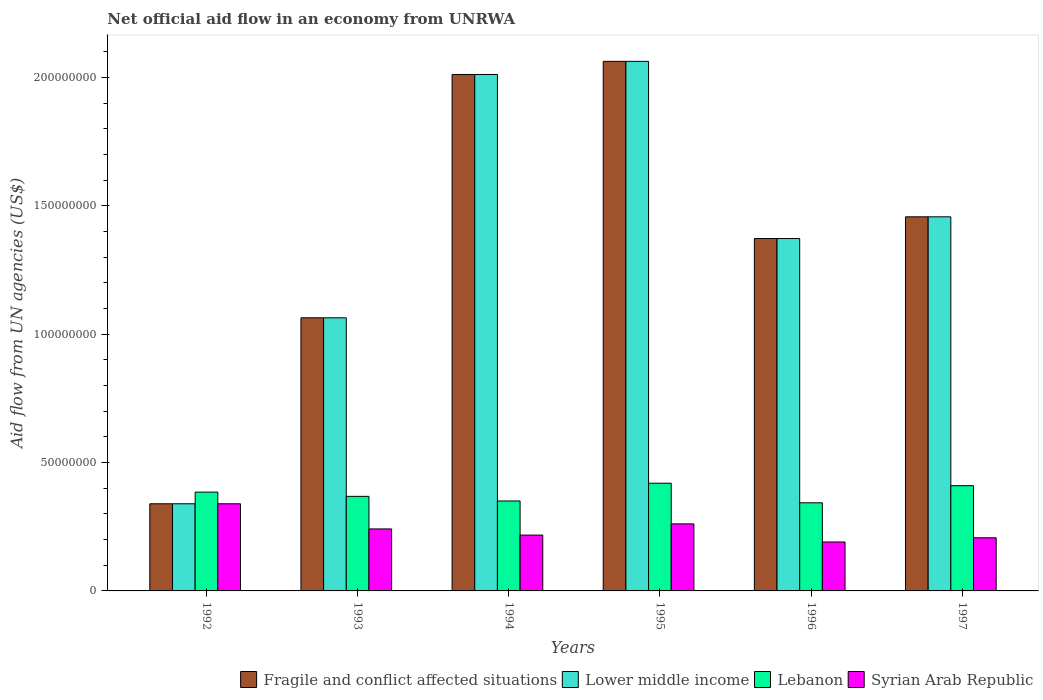How many bars are there on the 4th tick from the left?
Your answer should be very brief. 4. How many bars are there on the 3rd tick from the right?
Your answer should be very brief. 4. What is the label of the 1st group of bars from the left?
Make the answer very short. 1992. What is the net official aid flow in Fragile and conflict affected situations in 1997?
Provide a succinct answer. 1.46e+08. Across all years, what is the maximum net official aid flow in Fragile and conflict affected situations?
Your answer should be very brief. 2.06e+08. Across all years, what is the minimum net official aid flow in Fragile and conflict affected situations?
Offer a terse response. 3.40e+07. In which year was the net official aid flow in Lebanon minimum?
Offer a terse response. 1996. What is the total net official aid flow in Lower middle income in the graph?
Offer a terse response. 8.31e+08. What is the difference between the net official aid flow in Lower middle income in 1993 and that in 1994?
Provide a succinct answer. -9.48e+07. What is the difference between the net official aid flow in Lebanon in 1997 and the net official aid flow in Lower middle income in 1994?
Provide a succinct answer. -1.60e+08. What is the average net official aid flow in Lebanon per year?
Keep it short and to the point. 3.79e+07. In the year 1994, what is the difference between the net official aid flow in Lower middle income and net official aid flow in Lebanon?
Offer a terse response. 1.66e+08. In how many years, is the net official aid flow in Fragile and conflict affected situations greater than 160000000 US$?
Your answer should be compact. 2. What is the ratio of the net official aid flow in Lebanon in 1995 to that in 1996?
Offer a very short reply. 1.22. What is the difference between the highest and the second highest net official aid flow in Lower middle income?
Provide a succinct answer. 5.11e+06. What is the difference between the highest and the lowest net official aid flow in Fragile and conflict affected situations?
Make the answer very short. 1.72e+08. In how many years, is the net official aid flow in Lower middle income greater than the average net official aid flow in Lower middle income taken over all years?
Your answer should be very brief. 3. Is the sum of the net official aid flow in Lower middle income in 1992 and 1995 greater than the maximum net official aid flow in Lebanon across all years?
Your response must be concise. Yes. Is it the case that in every year, the sum of the net official aid flow in Fragile and conflict affected situations and net official aid flow in Syrian Arab Republic is greater than the sum of net official aid flow in Lebanon and net official aid flow in Lower middle income?
Your response must be concise. No. What does the 2nd bar from the left in 1992 represents?
Offer a terse response. Lower middle income. What does the 4th bar from the right in 1997 represents?
Your answer should be compact. Fragile and conflict affected situations. Is it the case that in every year, the sum of the net official aid flow in Lower middle income and net official aid flow in Syrian Arab Republic is greater than the net official aid flow in Fragile and conflict affected situations?
Offer a terse response. Yes. How many bars are there?
Give a very brief answer. 24. Are all the bars in the graph horizontal?
Offer a very short reply. No. What is the difference between two consecutive major ticks on the Y-axis?
Ensure brevity in your answer.  5.00e+07. Are the values on the major ticks of Y-axis written in scientific E-notation?
Give a very brief answer. No. Does the graph contain any zero values?
Give a very brief answer. No. What is the title of the graph?
Your response must be concise. Net official aid flow in an economy from UNRWA. Does "Micronesia" appear as one of the legend labels in the graph?
Your response must be concise. No. What is the label or title of the Y-axis?
Your answer should be compact. Aid flow from UN agencies (US$). What is the Aid flow from UN agencies (US$) of Fragile and conflict affected situations in 1992?
Make the answer very short. 3.40e+07. What is the Aid flow from UN agencies (US$) of Lower middle income in 1992?
Keep it short and to the point. 3.40e+07. What is the Aid flow from UN agencies (US$) in Lebanon in 1992?
Your answer should be compact. 3.85e+07. What is the Aid flow from UN agencies (US$) in Syrian Arab Republic in 1992?
Your answer should be compact. 3.40e+07. What is the Aid flow from UN agencies (US$) of Fragile and conflict affected situations in 1993?
Your answer should be compact. 1.06e+08. What is the Aid flow from UN agencies (US$) in Lower middle income in 1993?
Keep it short and to the point. 1.06e+08. What is the Aid flow from UN agencies (US$) of Lebanon in 1993?
Give a very brief answer. 3.68e+07. What is the Aid flow from UN agencies (US$) of Syrian Arab Republic in 1993?
Provide a short and direct response. 2.42e+07. What is the Aid flow from UN agencies (US$) in Fragile and conflict affected situations in 1994?
Your answer should be compact. 2.01e+08. What is the Aid flow from UN agencies (US$) in Lower middle income in 1994?
Your answer should be very brief. 2.01e+08. What is the Aid flow from UN agencies (US$) of Lebanon in 1994?
Provide a short and direct response. 3.50e+07. What is the Aid flow from UN agencies (US$) in Syrian Arab Republic in 1994?
Give a very brief answer. 2.18e+07. What is the Aid flow from UN agencies (US$) of Fragile and conflict affected situations in 1995?
Ensure brevity in your answer.  2.06e+08. What is the Aid flow from UN agencies (US$) of Lower middle income in 1995?
Provide a short and direct response. 2.06e+08. What is the Aid flow from UN agencies (US$) in Lebanon in 1995?
Give a very brief answer. 4.20e+07. What is the Aid flow from UN agencies (US$) of Syrian Arab Republic in 1995?
Keep it short and to the point. 2.61e+07. What is the Aid flow from UN agencies (US$) in Fragile and conflict affected situations in 1996?
Give a very brief answer. 1.37e+08. What is the Aid flow from UN agencies (US$) in Lower middle income in 1996?
Give a very brief answer. 1.37e+08. What is the Aid flow from UN agencies (US$) of Lebanon in 1996?
Ensure brevity in your answer.  3.43e+07. What is the Aid flow from UN agencies (US$) of Syrian Arab Republic in 1996?
Provide a short and direct response. 1.91e+07. What is the Aid flow from UN agencies (US$) in Fragile and conflict affected situations in 1997?
Keep it short and to the point. 1.46e+08. What is the Aid flow from UN agencies (US$) of Lower middle income in 1997?
Provide a short and direct response. 1.46e+08. What is the Aid flow from UN agencies (US$) in Lebanon in 1997?
Your response must be concise. 4.10e+07. What is the Aid flow from UN agencies (US$) of Syrian Arab Republic in 1997?
Make the answer very short. 2.07e+07. Across all years, what is the maximum Aid flow from UN agencies (US$) of Fragile and conflict affected situations?
Your answer should be compact. 2.06e+08. Across all years, what is the maximum Aid flow from UN agencies (US$) in Lower middle income?
Offer a very short reply. 2.06e+08. Across all years, what is the maximum Aid flow from UN agencies (US$) in Lebanon?
Your response must be concise. 4.20e+07. Across all years, what is the maximum Aid flow from UN agencies (US$) in Syrian Arab Republic?
Your answer should be very brief. 3.40e+07. Across all years, what is the minimum Aid flow from UN agencies (US$) in Fragile and conflict affected situations?
Provide a succinct answer. 3.40e+07. Across all years, what is the minimum Aid flow from UN agencies (US$) of Lower middle income?
Offer a very short reply. 3.40e+07. Across all years, what is the minimum Aid flow from UN agencies (US$) in Lebanon?
Offer a very short reply. 3.43e+07. Across all years, what is the minimum Aid flow from UN agencies (US$) in Syrian Arab Republic?
Give a very brief answer. 1.91e+07. What is the total Aid flow from UN agencies (US$) of Fragile and conflict affected situations in the graph?
Ensure brevity in your answer.  8.31e+08. What is the total Aid flow from UN agencies (US$) of Lower middle income in the graph?
Your response must be concise. 8.31e+08. What is the total Aid flow from UN agencies (US$) in Lebanon in the graph?
Ensure brevity in your answer.  2.28e+08. What is the total Aid flow from UN agencies (US$) in Syrian Arab Republic in the graph?
Give a very brief answer. 1.46e+08. What is the difference between the Aid flow from UN agencies (US$) of Fragile and conflict affected situations in 1992 and that in 1993?
Your answer should be compact. -7.24e+07. What is the difference between the Aid flow from UN agencies (US$) of Lower middle income in 1992 and that in 1993?
Offer a terse response. -7.24e+07. What is the difference between the Aid flow from UN agencies (US$) of Lebanon in 1992 and that in 1993?
Make the answer very short. 1.66e+06. What is the difference between the Aid flow from UN agencies (US$) in Syrian Arab Republic in 1992 and that in 1993?
Ensure brevity in your answer.  9.80e+06. What is the difference between the Aid flow from UN agencies (US$) in Fragile and conflict affected situations in 1992 and that in 1994?
Provide a short and direct response. -1.67e+08. What is the difference between the Aid flow from UN agencies (US$) of Lower middle income in 1992 and that in 1994?
Your response must be concise. -1.67e+08. What is the difference between the Aid flow from UN agencies (US$) of Lebanon in 1992 and that in 1994?
Your answer should be compact. 3.46e+06. What is the difference between the Aid flow from UN agencies (US$) of Syrian Arab Republic in 1992 and that in 1994?
Make the answer very short. 1.22e+07. What is the difference between the Aid flow from UN agencies (US$) in Fragile and conflict affected situations in 1992 and that in 1995?
Make the answer very short. -1.72e+08. What is the difference between the Aid flow from UN agencies (US$) of Lower middle income in 1992 and that in 1995?
Provide a short and direct response. -1.72e+08. What is the difference between the Aid flow from UN agencies (US$) in Lebanon in 1992 and that in 1995?
Give a very brief answer. -3.46e+06. What is the difference between the Aid flow from UN agencies (US$) in Syrian Arab Republic in 1992 and that in 1995?
Give a very brief answer. 7.84e+06. What is the difference between the Aid flow from UN agencies (US$) in Fragile and conflict affected situations in 1992 and that in 1996?
Keep it short and to the point. -1.03e+08. What is the difference between the Aid flow from UN agencies (US$) in Lower middle income in 1992 and that in 1996?
Make the answer very short. -1.03e+08. What is the difference between the Aid flow from UN agencies (US$) in Lebanon in 1992 and that in 1996?
Provide a short and direct response. 4.17e+06. What is the difference between the Aid flow from UN agencies (US$) of Syrian Arab Republic in 1992 and that in 1996?
Make the answer very short. 1.49e+07. What is the difference between the Aid flow from UN agencies (US$) in Fragile and conflict affected situations in 1992 and that in 1997?
Provide a short and direct response. -1.12e+08. What is the difference between the Aid flow from UN agencies (US$) of Lower middle income in 1992 and that in 1997?
Your answer should be very brief. -1.12e+08. What is the difference between the Aid flow from UN agencies (US$) in Lebanon in 1992 and that in 1997?
Provide a succinct answer. -2.50e+06. What is the difference between the Aid flow from UN agencies (US$) of Syrian Arab Republic in 1992 and that in 1997?
Provide a short and direct response. 1.32e+07. What is the difference between the Aid flow from UN agencies (US$) of Fragile and conflict affected situations in 1993 and that in 1994?
Keep it short and to the point. -9.48e+07. What is the difference between the Aid flow from UN agencies (US$) of Lower middle income in 1993 and that in 1994?
Ensure brevity in your answer.  -9.48e+07. What is the difference between the Aid flow from UN agencies (US$) of Lebanon in 1993 and that in 1994?
Provide a succinct answer. 1.80e+06. What is the difference between the Aid flow from UN agencies (US$) in Syrian Arab Republic in 1993 and that in 1994?
Your answer should be very brief. 2.40e+06. What is the difference between the Aid flow from UN agencies (US$) in Fragile and conflict affected situations in 1993 and that in 1995?
Offer a very short reply. -9.99e+07. What is the difference between the Aid flow from UN agencies (US$) in Lower middle income in 1993 and that in 1995?
Provide a succinct answer. -9.99e+07. What is the difference between the Aid flow from UN agencies (US$) in Lebanon in 1993 and that in 1995?
Keep it short and to the point. -5.12e+06. What is the difference between the Aid flow from UN agencies (US$) of Syrian Arab Republic in 1993 and that in 1995?
Your answer should be compact. -1.96e+06. What is the difference between the Aid flow from UN agencies (US$) of Fragile and conflict affected situations in 1993 and that in 1996?
Offer a terse response. -3.09e+07. What is the difference between the Aid flow from UN agencies (US$) in Lower middle income in 1993 and that in 1996?
Make the answer very short. -3.09e+07. What is the difference between the Aid flow from UN agencies (US$) of Lebanon in 1993 and that in 1996?
Make the answer very short. 2.51e+06. What is the difference between the Aid flow from UN agencies (US$) of Syrian Arab Republic in 1993 and that in 1996?
Provide a short and direct response. 5.09e+06. What is the difference between the Aid flow from UN agencies (US$) of Fragile and conflict affected situations in 1993 and that in 1997?
Your response must be concise. -3.93e+07. What is the difference between the Aid flow from UN agencies (US$) of Lower middle income in 1993 and that in 1997?
Give a very brief answer. -3.93e+07. What is the difference between the Aid flow from UN agencies (US$) of Lebanon in 1993 and that in 1997?
Offer a very short reply. -4.16e+06. What is the difference between the Aid flow from UN agencies (US$) in Syrian Arab Republic in 1993 and that in 1997?
Give a very brief answer. 3.45e+06. What is the difference between the Aid flow from UN agencies (US$) in Fragile and conflict affected situations in 1994 and that in 1995?
Keep it short and to the point. -5.11e+06. What is the difference between the Aid flow from UN agencies (US$) in Lower middle income in 1994 and that in 1995?
Give a very brief answer. -5.11e+06. What is the difference between the Aid flow from UN agencies (US$) in Lebanon in 1994 and that in 1995?
Your response must be concise. -6.92e+06. What is the difference between the Aid flow from UN agencies (US$) of Syrian Arab Republic in 1994 and that in 1995?
Keep it short and to the point. -4.36e+06. What is the difference between the Aid flow from UN agencies (US$) of Fragile and conflict affected situations in 1994 and that in 1996?
Provide a succinct answer. 6.39e+07. What is the difference between the Aid flow from UN agencies (US$) of Lower middle income in 1994 and that in 1996?
Ensure brevity in your answer.  6.39e+07. What is the difference between the Aid flow from UN agencies (US$) of Lebanon in 1994 and that in 1996?
Offer a terse response. 7.10e+05. What is the difference between the Aid flow from UN agencies (US$) in Syrian Arab Republic in 1994 and that in 1996?
Offer a very short reply. 2.69e+06. What is the difference between the Aid flow from UN agencies (US$) in Fragile and conflict affected situations in 1994 and that in 1997?
Offer a terse response. 5.55e+07. What is the difference between the Aid flow from UN agencies (US$) in Lower middle income in 1994 and that in 1997?
Make the answer very short. 5.55e+07. What is the difference between the Aid flow from UN agencies (US$) in Lebanon in 1994 and that in 1997?
Offer a very short reply. -5.96e+06. What is the difference between the Aid flow from UN agencies (US$) of Syrian Arab Republic in 1994 and that in 1997?
Your answer should be very brief. 1.05e+06. What is the difference between the Aid flow from UN agencies (US$) of Fragile and conflict affected situations in 1995 and that in 1996?
Offer a very short reply. 6.90e+07. What is the difference between the Aid flow from UN agencies (US$) of Lower middle income in 1995 and that in 1996?
Ensure brevity in your answer.  6.90e+07. What is the difference between the Aid flow from UN agencies (US$) of Lebanon in 1995 and that in 1996?
Provide a succinct answer. 7.63e+06. What is the difference between the Aid flow from UN agencies (US$) of Syrian Arab Republic in 1995 and that in 1996?
Give a very brief answer. 7.05e+06. What is the difference between the Aid flow from UN agencies (US$) of Fragile and conflict affected situations in 1995 and that in 1997?
Your answer should be very brief. 6.06e+07. What is the difference between the Aid flow from UN agencies (US$) in Lower middle income in 1995 and that in 1997?
Offer a very short reply. 6.06e+07. What is the difference between the Aid flow from UN agencies (US$) in Lebanon in 1995 and that in 1997?
Your answer should be compact. 9.60e+05. What is the difference between the Aid flow from UN agencies (US$) in Syrian Arab Republic in 1995 and that in 1997?
Provide a succinct answer. 5.41e+06. What is the difference between the Aid flow from UN agencies (US$) of Fragile and conflict affected situations in 1996 and that in 1997?
Make the answer very short. -8.46e+06. What is the difference between the Aid flow from UN agencies (US$) of Lower middle income in 1996 and that in 1997?
Provide a succinct answer. -8.46e+06. What is the difference between the Aid flow from UN agencies (US$) of Lebanon in 1996 and that in 1997?
Provide a short and direct response. -6.67e+06. What is the difference between the Aid flow from UN agencies (US$) of Syrian Arab Republic in 1996 and that in 1997?
Make the answer very short. -1.64e+06. What is the difference between the Aid flow from UN agencies (US$) in Fragile and conflict affected situations in 1992 and the Aid flow from UN agencies (US$) in Lower middle income in 1993?
Provide a succinct answer. -7.24e+07. What is the difference between the Aid flow from UN agencies (US$) in Fragile and conflict affected situations in 1992 and the Aid flow from UN agencies (US$) in Lebanon in 1993?
Your response must be concise. -2.89e+06. What is the difference between the Aid flow from UN agencies (US$) in Fragile and conflict affected situations in 1992 and the Aid flow from UN agencies (US$) in Syrian Arab Republic in 1993?
Your answer should be very brief. 9.80e+06. What is the difference between the Aid flow from UN agencies (US$) of Lower middle income in 1992 and the Aid flow from UN agencies (US$) of Lebanon in 1993?
Provide a short and direct response. -2.89e+06. What is the difference between the Aid flow from UN agencies (US$) of Lower middle income in 1992 and the Aid flow from UN agencies (US$) of Syrian Arab Republic in 1993?
Give a very brief answer. 9.80e+06. What is the difference between the Aid flow from UN agencies (US$) of Lebanon in 1992 and the Aid flow from UN agencies (US$) of Syrian Arab Republic in 1993?
Your response must be concise. 1.44e+07. What is the difference between the Aid flow from UN agencies (US$) in Fragile and conflict affected situations in 1992 and the Aid flow from UN agencies (US$) in Lower middle income in 1994?
Your response must be concise. -1.67e+08. What is the difference between the Aid flow from UN agencies (US$) in Fragile and conflict affected situations in 1992 and the Aid flow from UN agencies (US$) in Lebanon in 1994?
Your answer should be compact. -1.09e+06. What is the difference between the Aid flow from UN agencies (US$) of Fragile and conflict affected situations in 1992 and the Aid flow from UN agencies (US$) of Syrian Arab Republic in 1994?
Make the answer very short. 1.22e+07. What is the difference between the Aid flow from UN agencies (US$) of Lower middle income in 1992 and the Aid flow from UN agencies (US$) of Lebanon in 1994?
Keep it short and to the point. -1.09e+06. What is the difference between the Aid flow from UN agencies (US$) in Lower middle income in 1992 and the Aid flow from UN agencies (US$) in Syrian Arab Republic in 1994?
Make the answer very short. 1.22e+07. What is the difference between the Aid flow from UN agencies (US$) in Lebanon in 1992 and the Aid flow from UN agencies (US$) in Syrian Arab Republic in 1994?
Offer a terse response. 1.68e+07. What is the difference between the Aid flow from UN agencies (US$) in Fragile and conflict affected situations in 1992 and the Aid flow from UN agencies (US$) in Lower middle income in 1995?
Offer a terse response. -1.72e+08. What is the difference between the Aid flow from UN agencies (US$) in Fragile and conflict affected situations in 1992 and the Aid flow from UN agencies (US$) in Lebanon in 1995?
Provide a short and direct response. -8.01e+06. What is the difference between the Aid flow from UN agencies (US$) in Fragile and conflict affected situations in 1992 and the Aid flow from UN agencies (US$) in Syrian Arab Republic in 1995?
Make the answer very short. 7.84e+06. What is the difference between the Aid flow from UN agencies (US$) in Lower middle income in 1992 and the Aid flow from UN agencies (US$) in Lebanon in 1995?
Ensure brevity in your answer.  -8.01e+06. What is the difference between the Aid flow from UN agencies (US$) of Lower middle income in 1992 and the Aid flow from UN agencies (US$) of Syrian Arab Republic in 1995?
Your answer should be compact. 7.84e+06. What is the difference between the Aid flow from UN agencies (US$) in Lebanon in 1992 and the Aid flow from UN agencies (US$) in Syrian Arab Republic in 1995?
Keep it short and to the point. 1.24e+07. What is the difference between the Aid flow from UN agencies (US$) in Fragile and conflict affected situations in 1992 and the Aid flow from UN agencies (US$) in Lower middle income in 1996?
Provide a succinct answer. -1.03e+08. What is the difference between the Aid flow from UN agencies (US$) in Fragile and conflict affected situations in 1992 and the Aid flow from UN agencies (US$) in Lebanon in 1996?
Offer a very short reply. -3.80e+05. What is the difference between the Aid flow from UN agencies (US$) in Fragile and conflict affected situations in 1992 and the Aid flow from UN agencies (US$) in Syrian Arab Republic in 1996?
Give a very brief answer. 1.49e+07. What is the difference between the Aid flow from UN agencies (US$) in Lower middle income in 1992 and the Aid flow from UN agencies (US$) in Lebanon in 1996?
Your answer should be compact. -3.80e+05. What is the difference between the Aid flow from UN agencies (US$) of Lower middle income in 1992 and the Aid flow from UN agencies (US$) of Syrian Arab Republic in 1996?
Make the answer very short. 1.49e+07. What is the difference between the Aid flow from UN agencies (US$) in Lebanon in 1992 and the Aid flow from UN agencies (US$) in Syrian Arab Republic in 1996?
Offer a very short reply. 1.94e+07. What is the difference between the Aid flow from UN agencies (US$) in Fragile and conflict affected situations in 1992 and the Aid flow from UN agencies (US$) in Lower middle income in 1997?
Provide a short and direct response. -1.12e+08. What is the difference between the Aid flow from UN agencies (US$) of Fragile and conflict affected situations in 1992 and the Aid flow from UN agencies (US$) of Lebanon in 1997?
Offer a very short reply. -7.05e+06. What is the difference between the Aid flow from UN agencies (US$) of Fragile and conflict affected situations in 1992 and the Aid flow from UN agencies (US$) of Syrian Arab Republic in 1997?
Your answer should be compact. 1.32e+07. What is the difference between the Aid flow from UN agencies (US$) in Lower middle income in 1992 and the Aid flow from UN agencies (US$) in Lebanon in 1997?
Offer a terse response. -7.05e+06. What is the difference between the Aid flow from UN agencies (US$) in Lower middle income in 1992 and the Aid flow from UN agencies (US$) in Syrian Arab Republic in 1997?
Provide a succinct answer. 1.32e+07. What is the difference between the Aid flow from UN agencies (US$) in Lebanon in 1992 and the Aid flow from UN agencies (US$) in Syrian Arab Republic in 1997?
Make the answer very short. 1.78e+07. What is the difference between the Aid flow from UN agencies (US$) in Fragile and conflict affected situations in 1993 and the Aid flow from UN agencies (US$) in Lower middle income in 1994?
Ensure brevity in your answer.  -9.48e+07. What is the difference between the Aid flow from UN agencies (US$) in Fragile and conflict affected situations in 1993 and the Aid flow from UN agencies (US$) in Lebanon in 1994?
Offer a terse response. 7.14e+07. What is the difference between the Aid flow from UN agencies (US$) of Fragile and conflict affected situations in 1993 and the Aid flow from UN agencies (US$) of Syrian Arab Republic in 1994?
Give a very brief answer. 8.46e+07. What is the difference between the Aid flow from UN agencies (US$) of Lower middle income in 1993 and the Aid flow from UN agencies (US$) of Lebanon in 1994?
Your answer should be very brief. 7.14e+07. What is the difference between the Aid flow from UN agencies (US$) in Lower middle income in 1993 and the Aid flow from UN agencies (US$) in Syrian Arab Republic in 1994?
Your answer should be very brief. 8.46e+07. What is the difference between the Aid flow from UN agencies (US$) in Lebanon in 1993 and the Aid flow from UN agencies (US$) in Syrian Arab Republic in 1994?
Your response must be concise. 1.51e+07. What is the difference between the Aid flow from UN agencies (US$) in Fragile and conflict affected situations in 1993 and the Aid flow from UN agencies (US$) in Lower middle income in 1995?
Your answer should be compact. -9.99e+07. What is the difference between the Aid flow from UN agencies (US$) in Fragile and conflict affected situations in 1993 and the Aid flow from UN agencies (US$) in Lebanon in 1995?
Offer a terse response. 6.44e+07. What is the difference between the Aid flow from UN agencies (US$) of Fragile and conflict affected situations in 1993 and the Aid flow from UN agencies (US$) of Syrian Arab Republic in 1995?
Provide a short and direct response. 8.03e+07. What is the difference between the Aid flow from UN agencies (US$) of Lower middle income in 1993 and the Aid flow from UN agencies (US$) of Lebanon in 1995?
Provide a short and direct response. 6.44e+07. What is the difference between the Aid flow from UN agencies (US$) in Lower middle income in 1993 and the Aid flow from UN agencies (US$) in Syrian Arab Republic in 1995?
Provide a short and direct response. 8.03e+07. What is the difference between the Aid flow from UN agencies (US$) of Lebanon in 1993 and the Aid flow from UN agencies (US$) of Syrian Arab Republic in 1995?
Offer a very short reply. 1.07e+07. What is the difference between the Aid flow from UN agencies (US$) of Fragile and conflict affected situations in 1993 and the Aid flow from UN agencies (US$) of Lower middle income in 1996?
Provide a short and direct response. -3.09e+07. What is the difference between the Aid flow from UN agencies (US$) of Fragile and conflict affected situations in 1993 and the Aid flow from UN agencies (US$) of Lebanon in 1996?
Offer a terse response. 7.21e+07. What is the difference between the Aid flow from UN agencies (US$) in Fragile and conflict affected situations in 1993 and the Aid flow from UN agencies (US$) in Syrian Arab Republic in 1996?
Ensure brevity in your answer.  8.73e+07. What is the difference between the Aid flow from UN agencies (US$) of Lower middle income in 1993 and the Aid flow from UN agencies (US$) of Lebanon in 1996?
Provide a short and direct response. 7.21e+07. What is the difference between the Aid flow from UN agencies (US$) in Lower middle income in 1993 and the Aid flow from UN agencies (US$) in Syrian Arab Republic in 1996?
Your answer should be compact. 8.73e+07. What is the difference between the Aid flow from UN agencies (US$) of Lebanon in 1993 and the Aid flow from UN agencies (US$) of Syrian Arab Republic in 1996?
Your answer should be very brief. 1.78e+07. What is the difference between the Aid flow from UN agencies (US$) in Fragile and conflict affected situations in 1993 and the Aid flow from UN agencies (US$) in Lower middle income in 1997?
Provide a short and direct response. -3.93e+07. What is the difference between the Aid flow from UN agencies (US$) of Fragile and conflict affected situations in 1993 and the Aid flow from UN agencies (US$) of Lebanon in 1997?
Give a very brief answer. 6.54e+07. What is the difference between the Aid flow from UN agencies (US$) of Fragile and conflict affected situations in 1993 and the Aid flow from UN agencies (US$) of Syrian Arab Republic in 1997?
Your response must be concise. 8.57e+07. What is the difference between the Aid flow from UN agencies (US$) in Lower middle income in 1993 and the Aid flow from UN agencies (US$) in Lebanon in 1997?
Ensure brevity in your answer.  6.54e+07. What is the difference between the Aid flow from UN agencies (US$) of Lower middle income in 1993 and the Aid flow from UN agencies (US$) of Syrian Arab Republic in 1997?
Offer a terse response. 8.57e+07. What is the difference between the Aid flow from UN agencies (US$) in Lebanon in 1993 and the Aid flow from UN agencies (US$) in Syrian Arab Republic in 1997?
Give a very brief answer. 1.61e+07. What is the difference between the Aid flow from UN agencies (US$) in Fragile and conflict affected situations in 1994 and the Aid flow from UN agencies (US$) in Lower middle income in 1995?
Offer a terse response. -5.11e+06. What is the difference between the Aid flow from UN agencies (US$) in Fragile and conflict affected situations in 1994 and the Aid flow from UN agencies (US$) in Lebanon in 1995?
Your answer should be very brief. 1.59e+08. What is the difference between the Aid flow from UN agencies (US$) in Fragile and conflict affected situations in 1994 and the Aid flow from UN agencies (US$) in Syrian Arab Republic in 1995?
Offer a very short reply. 1.75e+08. What is the difference between the Aid flow from UN agencies (US$) of Lower middle income in 1994 and the Aid flow from UN agencies (US$) of Lebanon in 1995?
Offer a very short reply. 1.59e+08. What is the difference between the Aid flow from UN agencies (US$) of Lower middle income in 1994 and the Aid flow from UN agencies (US$) of Syrian Arab Republic in 1995?
Offer a very short reply. 1.75e+08. What is the difference between the Aid flow from UN agencies (US$) in Lebanon in 1994 and the Aid flow from UN agencies (US$) in Syrian Arab Republic in 1995?
Your response must be concise. 8.93e+06. What is the difference between the Aid flow from UN agencies (US$) in Fragile and conflict affected situations in 1994 and the Aid flow from UN agencies (US$) in Lower middle income in 1996?
Offer a terse response. 6.39e+07. What is the difference between the Aid flow from UN agencies (US$) of Fragile and conflict affected situations in 1994 and the Aid flow from UN agencies (US$) of Lebanon in 1996?
Offer a very short reply. 1.67e+08. What is the difference between the Aid flow from UN agencies (US$) in Fragile and conflict affected situations in 1994 and the Aid flow from UN agencies (US$) in Syrian Arab Republic in 1996?
Make the answer very short. 1.82e+08. What is the difference between the Aid flow from UN agencies (US$) of Lower middle income in 1994 and the Aid flow from UN agencies (US$) of Lebanon in 1996?
Provide a short and direct response. 1.67e+08. What is the difference between the Aid flow from UN agencies (US$) of Lower middle income in 1994 and the Aid flow from UN agencies (US$) of Syrian Arab Republic in 1996?
Keep it short and to the point. 1.82e+08. What is the difference between the Aid flow from UN agencies (US$) in Lebanon in 1994 and the Aid flow from UN agencies (US$) in Syrian Arab Republic in 1996?
Make the answer very short. 1.60e+07. What is the difference between the Aid flow from UN agencies (US$) of Fragile and conflict affected situations in 1994 and the Aid flow from UN agencies (US$) of Lower middle income in 1997?
Make the answer very short. 5.55e+07. What is the difference between the Aid flow from UN agencies (US$) of Fragile and conflict affected situations in 1994 and the Aid flow from UN agencies (US$) of Lebanon in 1997?
Your answer should be compact. 1.60e+08. What is the difference between the Aid flow from UN agencies (US$) of Fragile and conflict affected situations in 1994 and the Aid flow from UN agencies (US$) of Syrian Arab Republic in 1997?
Your answer should be very brief. 1.80e+08. What is the difference between the Aid flow from UN agencies (US$) of Lower middle income in 1994 and the Aid flow from UN agencies (US$) of Lebanon in 1997?
Provide a short and direct response. 1.60e+08. What is the difference between the Aid flow from UN agencies (US$) in Lower middle income in 1994 and the Aid flow from UN agencies (US$) in Syrian Arab Republic in 1997?
Offer a terse response. 1.80e+08. What is the difference between the Aid flow from UN agencies (US$) in Lebanon in 1994 and the Aid flow from UN agencies (US$) in Syrian Arab Republic in 1997?
Offer a very short reply. 1.43e+07. What is the difference between the Aid flow from UN agencies (US$) of Fragile and conflict affected situations in 1995 and the Aid flow from UN agencies (US$) of Lower middle income in 1996?
Give a very brief answer. 6.90e+07. What is the difference between the Aid flow from UN agencies (US$) of Fragile and conflict affected situations in 1995 and the Aid flow from UN agencies (US$) of Lebanon in 1996?
Offer a terse response. 1.72e+08. What is the difference between the Aid flow from UN agencies (US$) in Fragile and conflict affected situations in 1995 and the Aid flow from UN agencies (US$) in Syrian Arab Republic in 1996?
Make the answer very short. 1.87e+08. What is the difference between the Aid flow from UN agencies (US$) in Lower middle income in 1995 and the Aid flow from UN agencies (US$) in Lebanon in 1996?
Make the answer very short. 1.72e+08. What is the difference between the Aid flow from UN agencies (US$) in Lower middle income in 1995 and the Aid flow from UN agencies (US$) in Syrian Arab Republic in 1996?
Your answer should be compact. 1.87e+08. What is the difference between the Aid flow from UN agencies (US$) of Lebanon in 1995 and the Aid flow from UN agencies (US$) of Syrian Arab Republic in 1996?
Make the answer very short. 2.29e+07. What is the difference between the Aid flow from UN agencies (US$) in Fragile and conflict affected situations in 1995 and the Aid flow from UN agencies (US$) in Lower middle income in 1997?
Keep it short and to the point. 6.06e+07. What is the difference between the Aid flow from UN agencies (US$) in Fragile and conflict affected situations in 1995 and the Aid flow from UN agencies (US$) in Lebanon in 1997?
Provide a short and direct response. 1.65e+08. What is the difference between the Aid flow from UN agencies (US$) in Fragile and conflict affected situations in 1995 and the Aid flow from UN agencies (US$) in Syrian Arab Republic in 1997?
Your response must be concise. 1.86e+08. What is the difference between the Aid flow from UN agencies (US$) of Lower middle income in 1995 and the Aid flow from UN agencies (US$) of Lebanon in 1997?
Give a very brief answer. 1.65e+08. What is the difference between the Aid flow from UN agencies (US$) in Lower middle income in 1995 and the Aid flow from UN agencies (US$) in Syrian Arab Republic in 1997?
Your answer should be very brief. 1.86e+08. What is the difference between the Aid flow from UN agencies (US$) of Lebanon in 1995 and the Aid flow from UN agencies (US$) of Syrian Arab Republic in 1997?
Make the answer very short. 2.13e+07. What is the difference between the Aid flow from UN agencies (US$) in Fragile and conflict affected situations in 1996 and the Aid flow from UN agencies (US$) in Lower middle income in 1997?
Offer a terse response. -8.46e+06. What is the difference between the Aid flow from UN agencies (US$) in Fragile and conflict affected situations in 1996 and the Aid flow from UN agencies (US$) in Lebanon in 1997?
Offer a very short reply. 9.63e+07. What is the difference between the Aid flow from UN agencies (US$) of Fragile and conflict affected situations in 1996 and the Aid flow from UN agencies (US$) of Syrian Arab Republic in 1997?
Provide a short and direct response. 1.17e+08. What is the difference between the Aid flow from UN agencies (US$) in Lower middle income in 1996 and the Aid flow from UN agencies (US$) in Lebanon in 1997?
Give a very brief answer. 9.63e+07. What is the difference between the Aid flow from UN agencies (US$) of Lower middle income in 1996 and the Aid flow from UN agencies (US$) of Syrian Arab Republic in 1997?
Your answer should be compact. 1.17e+08. What is the difference between the Aid flow from UN agencies (US$) of Lebanon in 1996 and the Aid flow from UN agencies (US$) of Syrian Arab Republic in 1997?
Offer a very short reply. 1.36e+07. What is the average Aid flow from UN agencies (US$) of Fragile and conflict affected situations per year?
Your answer should be compact. 1.38e+08. What is the average Aid flow from UN agencies (US$) of Lower middle income per year?
Give a very brief answer. 1.38e+08. What is the average Aid flow from UN agencies (US$) in Lebanon per year?
Provide a short and direct response. 3.79e+07. What is the average Aid flow from UN agencies (US$) in Syrian Arab Republic per year?
Provide a succinct answer. 2.43e+07. In the year 1992, what is the difference between the Aid flow from UN agencies (US$) of Fragile and conflict affected situations and Aid flow from UN agencies (US$) of Lower middle income?
Give a very brief answer. 0. In the year 1992, what is the difference between the Aid flow from UN agencies (US$) in Fragile and conflict affected situations and Aid flow from UN agencies (US$) in Lebanon?
Provide a short and direct response. -4.55e+06. In the year 1992, what is the difference between the Aid flow from UN agencies (US$) of Lower middle income and Aid flow from UN agencies (US$) of Lebanon?
Your response must be concise. -4.55e+06. In the year 1992, what is the difference between the Aid flow from UN agencies (US$) of Lebanon and Aid flow from UN agencies (US$) of Syrian Arab Republic?
Your answer should be compact. 4.55e+06. In the year 1993, what is the difference between the Aid flow from UN agencies (US$) of Fragile and conflict affected situations and Aid flow from UN agencies (US$) of Lebanon?
Your response must be concise. 6.96e+07. In the year 1993, what is the difference between the Aid flow from UN agencies (US$) of Fragile and conflict affected situations and Aid flow from UN agencies (US$) of Syrian Arab Republic?
Offer a very short reply. 8.22e+07. In the year 1993, what is the difference between the Aid flow from UN agencies (US$) in Lower middle income and Aid flow from UN agencies (US$) in Lebanon?
Your answer should be compact. 6.96e+07. In the year 1993, what is the difference between the Aid flow from UN agencies (US$) in Lower middle income and Aid flow from UN agencies (US$) in Syrian Arab Republic?
Make the answer very short. 8.22e+07. In the year 1993, what is the difference between the Aid flow from UN agencies (US$) in Lebanon and Aid flow from UN agencies (US$) in Syrian Arab Republic?
Give a very brief answer. 1.27e+07. In the year 1994, what is the difference between the Aid flow from UN agencies (US$) in Fragile and conflict affected situations and Aid flow from UN agencies (US$) in Lower middle income?
Provide a succinct answer. 0. In the year 1994, what is the difference between the Aid flow from UN agencies (US$) of Fragile and conflict affected situations and Aid flow from UN agencies (US$) of Lebanon?
Offer a very short reply. 1.66e+08. In the year 1994, what is the difference between the Aid flow from UN agencies (US$) of Fragile and conflict affected situations and Aid flow from UN agencies (US$) of Syrian Arab Republic?
Provide a short and direct response. 1.79e+08. In the year 1994, what is the difference between the Aid flow from UN agencies (US$) in Lower middle income and Aid flow from UN agencies (US$) in Lebanon?
Provide a short and direct response. 1.66e+08. In the year 1994, what is the difference between the Aid flow from UN agencies (US$) of Lower middle income and Aid flow from UN agencies (US$) of Syrian Arab Republic?
Offer a terse response. 1.79e+08. In the year 1994, what is the difference between the Aid flow from UN agencies (US$) of Lebanon and Aid flow from UN agencies (US$) of Syrian Arab Republic?
Give a very brief answer. 1.33e+07. In the year 1995, what is the difference between the Aid flow from UN agencies (US$) in Fragile and conflict affected situations and Aid flow from UN agencies (US$) in Lebanon?
Your answer should be compact. 1.64e+08. In the year 1995, what is the difference between the Aid flow from UN agencies (US$) in Fragile and conflict affected situations and Aid flow from UN agencies (US$) in Syrian Arab Republic?
Your answer should be compact. 1.80e+08. In the year 1995, what is the difference between the Aid flow from UN agencies (US$) in Lower middle income and Aid flow from UN agencies (US$) in Lebanon?
Ensure brevity in your answer.  1.64e+08. In the year 1995, what is the difference between the Aid flow from UN agencies (US$) in Lower middle income and Aid flow from UN agencies (US$) in Syrian Arab Republic?
Provide a succinct answer. 1.80e+08. In the year 1995, what is the difference between the Aid flow from UN agencies (US$) of Lebanon and Aid flow from UN agencies (US$) of Syrian Arab Republic?
Provide a succinct answer. 1.58e+07. In the year 1996, what is the difference between the Aid flow from UN agencies (US$) in Fragile and conflict affected situations and Aid flow from UN agencies (US$) in Lebanon?
Your response must be concise. 1.03e+08. In the year 1996, what is the difference between the Aid flow from UN agencies (US$) in Fragile and conflict affected situations and Aid flow from UN agencies (US$) in Syrian Arab Republic?
Your answer should be compact. 1.18e+08. In the year 1996, what is the difference between the Aid flow from UN agencies (US$) of Lower middle income and Aid flow from UN agencies (US$) of Lebanon?
Your answer should be compact. 1.03e+08. In the year 1996, what is the difference between the Aid flow from UN agencies (US$) of Lower middle income and Aid flow from UN agencies (US$) of Syrian Arab Republic?
Offer a terse response. 1.18e+08. In the year 1996, what is the difference between the Aid flow from UN agencies (US$) of Lebanon and Aid flow from UN agencies (US$) of Syrian Arab Republic?
Provide a short and direct response. 1.53e+07. In the year 1997, what is the difference between the Aid flow from UN agencies (US$) of Fragile and conflict affected situations and Aid flow from UN agencies (US$) of Lebanon?
Your response must be concise. 1.05e+08. In the year 1997, what is the difference between the Aid flow from UN agencies (US$) in Fragile and conflict affected situations and Aid flow from UN agencies (US$) in Syrian Arab Republic?
Keep it short and to the point. 1.25e+08. In the year 1997, what is the difference between the Aid flow from UN agencies (US$) of Lower middle income and Aid flow from UN agencies (US$) of Lebanon?
Your response must be concise. 1.05e+08. In the year 1997, what is the difference between the Aid flow from UN agencies (US$) in Lower middle income and Aid flow from UN agencies (US$) in Syrian Arab Republic?
Give a very brief answer. 1.25e+08. In the year 1997, what is the difference between the Aid flow from UN agencies (US$) of Lebanon and Aid flow from UN agencies (US$) of Syrian Arab Republic?
Offer a terse response. 2.03e+07. What is the ratio of the Aid flow from UN agencies (US$) of Fragile and conflict affected situations in 1992 to that in 1993?
Provide a succinct answer. 0.32. What is the ratio of the Aid flow from UN agencies (US$) of Lower middle income in 1992 to that in 1993?
Provide a short and direct response. 0.32. What is the ratio of the Aid flow from UN agencies (US$) of Lebanon in 1992 to that in 1993?
Offer a terse response. 1.05. What is the ratio of the Aid flow from UN agencies (US$) of Syrian Arab Republic in 1992 to that in 1993?
Ensure brevity in your answer.  1.41. What is the ratio of the Aid flow from UN agencies (US$) of Fragile and conflict affected situations in 1992 to that in 1994?
Provide a short and direct response. 0.17. What is the ratio of the Aid flow from UN agencies (US$) of Lower middle income in 1992 to that in 1994?
Make the answer very short. 0.17. What is the ratio of the Aid flow from UN agencies (US$) of Lebanon in 1992 to that in 1994?
Your answer should be compact. 1.1. What is the ratio of the Aid flow from UN agencies (US$) of Syrian Arab Republic in 1992 to that in 1994?
Make the answer very short. 1.56. What is the ratio of the Aid flow from UN agencies (US$) in Fragile and conflict affected situations in 1992 to that in 1995?
Ensure brevity in your answer.  0.16. What is the ratio of the Aid flow from UN agencies (US$) in Lower middle income in 1992 to that in 1995?
Offer a very short reply. 0.16. What is the ratio of the Aid flow from UN agencies (US$) in Lebanon in 1992 to that in 1995?
Your answer should be very brief. 0.92. What is the ratio of the Aid flow from UN agencies (US$) in Syrian Arab Republic in 1992 to that in 1995?
Make the answer very short. 1.3. What is the ratio of the Aid flow from UN agencies (US$) in Fragile and conflict affected situations in 1992 to that in 1996?
Your answer should be compact. 0.25. What is the ratio of the Aid flow from UN agencies (US$) of Lower middle income in 1992 to that in 1996?
Make the answer very short. 0.25. What is the ratio of the Aid flow from UN agencies (US$) of Lebanon in 1992 to that in 1996?
Your answer should be compact. 1.12. What is the ratio of the Aid flow from UN agencies (US$) in Syrian Arab Republic in 1992 to that in 1996?
Keep it short and to the point. 1.78. What is the ratio of the Aid flow from UN agencies (US$) in Fragile and conflict affected situations in 1992 to that in 1997?
Offer a terse response. 0.23. What is the ratio of the Aid flow from UN agencies (US$) in Lower middle income in 1992 to that in 1997?
Your answer should be very brief. 0.23. What is the ratio of the Aid flow from UN agencies (US$) in Lebanon in 1992 to that in 1997?
Your answer should be compact. 0.94. What is the ratio of the Aid flow from UN agencies (US$) in Syrian Arab Republic in 1992 to that in 1997?
Make the answer very short. 1.64. What is the ratio of the Aid flow from UN agencies (US$) of Fragile and conflict affected situations in 1993 to that in 1994?
Offer a terse response. 0.53. What is the ratio of the Aid flow from UN agencies (US$) of Lower middle income in 1993 to that in 1994?
Your answer should be compact. 0.53. What is the ratio of the Aid flow from UN agencies (US$) of Lebanon in 1993 to that in 1994?
Your answer should be compact. 1.05. What is the ratio of the Aid flow from UN agencies (US$) of Syrian Arab Republic in 1993 to that in 1994?
Offer a terse response. 1.11. What is the ratio of the Aid flow from UN agencies (US$) in Fragile and conflict affected situations in 1993 to that in 1995?
Your answer should be compact. 0.52. What is the ratio of the Aid flow from UN agencies (US$) in Lower middle income in 1993 to that in 1995?
Offer a terse response. 0.52. What is the ratio of the Aid flow from UN agencies (US$) in Lebanon in 1993 to that in 1995?
Your answer should be compact. 0.88. What is the ratio of the Aid flow from UN agencies (US$) in Syrian Arab Republic in 1993 to that in 1995?
Provide a short and direct response. 0.92. What is the ratio of the Aid flow from UN agencies (US$) in Fragile and conflict affected situations in 1993 to that in 1996?
Provide a short and direct response. 0.78. What is the ratio of the Aid flow from UN agencies (US$) in Lower middle income in 1993 to that in 1996?
Give a very brief answer. 0.78. What is the ratio of the Aid flow from UN agencies (US$) of Lebanon in 1993 to that in 1996?
Give a very brief answer. 1.07. What is the ratio of the Aid flow from UN agencies (US$) of Syrian Arab Republic in 1993 to that in 1996?
Your answer should be very brief. 1.27. What is the ratio of the Aid flow from UN agencies (US$) of Fragile and conflict affected situations in 1993 to that in 1997?
Offer a very short reply. 0.73. What is the ratio of the Aid flow from UN agencies (US$) in Lower middle income in 1993 to that in 1997?
Your response must be concise. 0.73. What is the ratio of the Aid flow from UN agencies (US$) in Lebanon in 1993 to that in 1997?
Your answer should be compact. 0.9. What is the ratio of the Aid flow from UN agencies (US$) of Fragile and conflict affected situations in 1994 to that in 1995?
Your response must be concise. 0.98. What is the ratio of the Aid flow from UN agencies (US$) of Lower middle income in 1994 to that in 1995?
Offer a terse response. 0.98. What is the ratio of the Aid flow from UN agencies (US$) in Lebanon in 1994 to that in 1995?
Give a very brief answer. 0.84. What is the ratio of the Aid flow from UN agencies (US$) in Syrian Arab Republic in 1994 to that in 1995?
Offer a terse response. 0.83. What is the ratio of the Aid flow from UN agencies (US$) of Fragile and conflict affected situations in 1994 to that in 1996?
Your answer should be very brief. 1.47. What is the ratio of the Aid flow from UN agencies (US$) of Lower middle income in 1994 to that in 1996?
Offer a terse response. 1.47. What is the ratio of the Aid flow from UN agencies (US$) of Lebanon in 1994 to that in 1996?
Your response must be concise. 1.02. What is the ratio of the Aid flow from UN agencies (US$) of Syrian Arab Republic in 1994 to that in 1996?
Make the answer very short. 1.14. What is the ratio of the Aid flow from UN agencies (US$) in Fragile and conflict affected situations in 1994 to that in 1997?
Your response must be concise. 1.38. What is the ratio of the Aid flow from UN agencies (US$) in Lower middle income in 1994 to that in 1997?
Ensure brevity in your answer.  1.38. What is the ratio of the Aid flow from UN agencies (US$) in Lebanon in 1994 to that in 1997?
Give a very brief answer. 0.85. What is the ratio of the Aid flow from UN agencies (US$) in Syrian Arab Republic in 1994 to that in 1997?
Give a very brief answer. 1.05. What is the ratio of the Aid flow from UN agencies (US$) of Fragile and conflict affected situations in 1995 to that in 1996?
Your answer should be compact. 1.5. What is the ratio of the Aid flow from UN agencies (US$) of Lower middle income in 1995 to that in 1996?
Offer a terse response. 1.5. What is the ratio of the Aid flow from UN agencies (US$) of Lebanon in 1995 to that in 1996?
Ensure brevity in your answer.  1.22. What is the ratio of the Aid flow from UN agencies (US$) in Syrian Arab Republic in 1995 to that in 1996?
Your response must be concise. 1.37. What is the ratio of the Aid flow from UN agencies (US$) of Fragile and conflict affected situations in 1995 to that in 1997?
Keep it short and to the point. 1.42. What is the ratio of the Aid flow from UN agencies (US$) of Lower middle income in 1995 to that in 1997?
Keep it short and to the point. 1.42. What is the ratio of the Aid flow from UN agencies (US$) of Lebanon in 1995 to that in 1997?
Make the answer very short. 1.02. What is the ratio of the Aid flow from UN agencies (US$) of Syrian Arab Republic in 1995 to that in 1997?
Your response must be concise. 1.26. What is the ratio of the Aid flow from UN agencies (US$) of Fragile and conflict affected situations in 1996 to that in 1997?
Your answer should be very brief. 0.94. What is the ratio of the Aid flow from UN agencies (US$) of Lower middle income in 1996 to that in 1997?
Give a very brief answer. 0.94. What is the ratio of the Aid flow from UN agencies (US$) in Lebanon in 1996 to that in 1997?
Give a very brief answer. 0.84. What is the ratio of the Aid flow from UN agencies (US$) in Syrian Arab Republic in 1996 to that in 1997?
Keep it short and to the point. 0.92. What is the difference between the highest and the second highest Aid flow from UN agencies (US$) in Fragile and conflict affected situations?
Your answer should be very brief. 5.11e+06. What is the difference between the highest and the second highest Aid flow from UN agencies (US$) of Lower middle income?
Make the answer very short. 5.11e+06. What is the difference between the highest and the second highest Aid flow from UN agencies (US$) of Lebanon?
Your response must be concise. 9.60e+05. What is the difference between the highest and the second highest Aid flow from UN agencies (US$) in Syrian Arab Republic?
Offer a very short reply. 7.84e+06. What is the difference between the highest and the lowest Aid flow from UN agencies (US$) in Fragile and conflict affected situations?
Your answer should be compact. 1.72e+08. What is the difference between the highest and the lowest Aid flow from UN agencies (US$) in Lower middle income?
Give a very brief answer. 1.72e+08. What is the difference between the highest and the lowest Aid flow from UN agencies (US$) in Lebanon?
Offer a terse response. 7.63e+06. What is the difference between the highest and the lowest Aid flow from UN agencies (US$) of Syrian Arab Republic?
Offer a very short reply. 1.49e+07. 